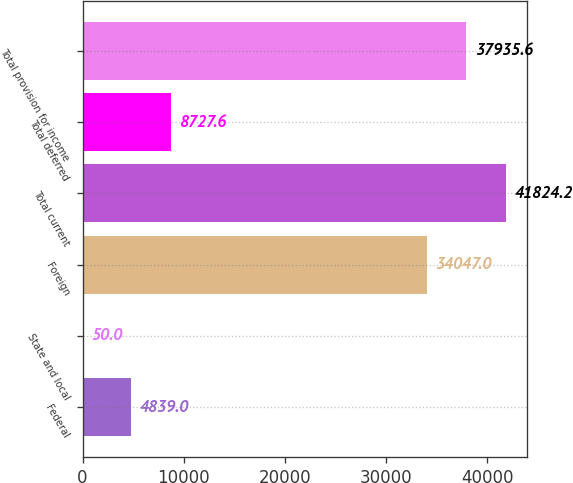<chart> <loc_0><loc_0><loc_500><loc_500><bar_chart><fcel>Federal<fcel>State and local<fcel>Foreign<fcel>Total current<fcel>Total deferred<fcel>Total provision for income<nl><fcel>4839<fcel>50<fcel>34047<fcel>41824.2<fcel>8727.6<fcel>37935.6<nl></chart> 